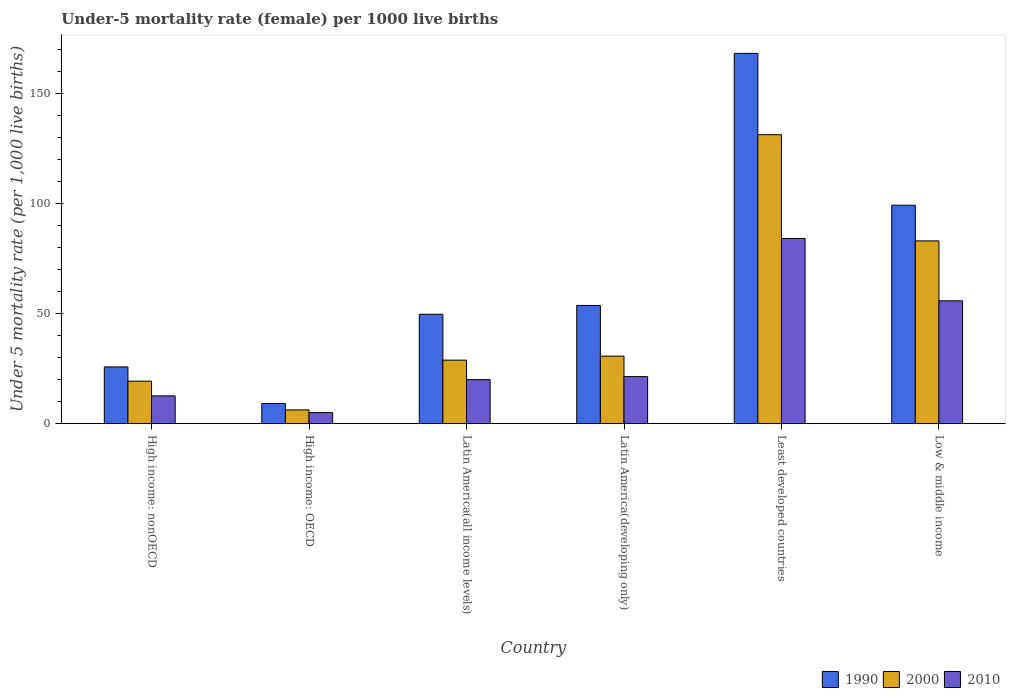How many groups of bars are there?
Offer a terse response. 6. Are the number of bars on each tick of the X-axis equal?
Offer a terse response. Yes. How many bars are there on the 1st tick from the left?
Ensure brevity in your answer.  3. In how many cases, is the number of bars for a given country not equal to the number of legend labels?
Provide a short and direct response. 0. What is the under-five mortality rate in 2000 in Latin America(all income levels)?
Offer a terse response. 28.87. Across all countries, what is the maximum under-five mortality rate in 2010?
Give a very brief answer. 84.09. Across all countries, what is the minimum under-five mortality rate in 2000?
Provide a succinct answer. 6.28. In which country was the under-five mortality rate in 2000 maximum?
Offer a terse response. Least developed countries. In which country was the under-five mortality rate in 1990 minimum?
Provide a short and direct response. High income: OECD. What is the total under-five mortality rate in 1990 in the graph?
Provide a succinct answer. 405.7. What is the difference between the under-five mortality rate in 2000 in Latin America(all income levels) and that in Low & middle income?
Your answer should be very brief. -54.13. What is the difference between the under-five mortality rate in 2010 in Latin America(all income levels) and the under-five mortality rate in 1990 in Least developed countries?
Ensure brevity in your answer.  -148.11. What is the average under-five mortality rate in 2010 per country?
Offer a terse response. 33.17. What is the difference between the under-five mortality rate of/in 2000 and under-five mortality rate of/in 2010 in Latin America(developing only)?
Your response must be concise. 9.3. What is the ratio of the under-five mortality rate in 1990 in Latin America(developing only) to that in Low & middle income?
Provide a succinct answer. 0.54. Is the difference between the under-five mortality rate in 2000 in Latin America(all income levels) and Least developed countries greater than the difference between the under-five mortality rate in 2010 in Latin America(all income levels) and Least developed countries?
Provide a short and direct response. No. What is the difference between the highest and the second highest under-five mortality rate in 2000?
Make the answer very short. -48.2. What is the difference between the highest and the lowest under-five mortality rate in 2000?
Provide a short and direct response. 124.92. In how many countries, is the under-five mortality rate in 2000 greater than the average under-five mortality rate in 2000 taken over all countries?
Provide a short and direct response. 2. Is the sum of the under-five mortality rate in 1990 in Latin America(developing only) and Low & middle income greater than the maximum under-five mortality rate in 2010 across all countries?
Give a very brief answer. Yes. Is it the case that in every country, the sum of the under-five mortality rate in 2010 and under-five mortality rate in 1990 is greater than the under-five mortality rate in 2000?
Give a very brief answer. Yes. Are all the bars in the graph horizontal?
Ensure brevity in your answer.  No. What is the difference between two consecutive major ticks on the Y-axis?
Provide a succinct answer. 50. Are the values on the major ticks of Y-axis written in scientific E-notation?
Offer a very short reply. No. How many legend labels are there?
Your answer should be very brief. 3. What is the title of the graph?
Ensure brevity in your answer.  Under-5 mortality rate (female) per 1000 live births. What is the label or title of the Y-axis?
Your response must be concise. Under 5 mortality rate (per 1,0 live births). What is the Under 5 mortality rate (per 1,000 live births) in 1990 in High income: nonOECD?
Give a very brief answer. 25.8. What is the Under 5 mortality rate (per 1,000 live births) in 2000 in High income: nonOECD?
Offer a very short reply. 19.34. What is the Under 5 mortality rate (per 1,000 live births) in 2010 in High income: nonOECD?
Give a very brief answer. 12.65. What is the Under 5 mortality rate (per 1,000 live births) of 1990 in High income: OECD?
Your answer should be compact. 9.18. What is the Under 5 mortality rate (per 1,000 live births) in 2000 in High income: OECD?
Your answer should be compact. 6.28. What is the Under 5 mortality rate (per 1,000 live births) of 2010 in High income: OECD?
Offer a terse response. 5.04. What is the Under 5 mortality rate (per 1,000 live births) of 1990 in Latin America(all income levels)?
Provide a succinct answer. 49.7. What is the Under 5 mortality rate (per 1,000 live births) in 2000 in Latin America(all income levels)?
Offer a very short reply. 28.87. What is the Under 5 mortality rate (per 1,000 live births) in 2010 in Latin America(all income levels)?
Your answer should be very brief. 20.02. What is the Under 5 mortality rate (per 1,000 live births) of 1990 in Latin America(developing only)?
Your response must be concise. 53.7. What is the Under 5 mortality rate (per 1,000 live births) in 2000 in Latin America(developing only)?
Ensure brevity in your answer.  30.7. What is the Under 5 mortality rate (per 1,000 live births) in 2010 in Latin America(developing only)?
Provide a short and direct response. 21.4. What is the Under 5 mortality rate (per 1,000 live births) of 1990 in Least developed countries?
Make the answer very short. 168.12. What is the Under 5 mortality rate (per 1,000 live births) in 2000 in Least developed countries?
Provide a short and direct response. 131.2. What is the Under 5 mortality rate (per 1,000 live births) of 2010 in Least developed countries?
Give a very brief answer. 84.09. What is the Under 5 mortality rate (per 1,000 live births) of 1990 in Low & middle income?
Provide a short and direct response. 99.2. What is the Under 5 mortality rate (per 1,000 live births) of 2000 in Low & middle income?
Your answer should be very brief. 83. What is the Under 5 mortality rate (per 1,000 live births) in 2010 in Low & middle income?
Your response must be concise. 55.8. Across all countries, what is the maximum Under 5 mortality rate (per 1,000 live births) of 1990?
Keep it short and to the point. 168.12. Across all countries, what is the maximum Under 5 mortality rate (per 1,000 live births) in 2000?
Your answer should be compact. 131.2. Across all countries, what is the maximum Under 5 mortality rate (per 1,000 live births) of 2010?
Provide a short and direct response. 84.09. Across all countries, what is the minimum Under 5 mortality rate (per 1,000 live births) in 1990?
Ensure brevity in your answer.  9.18. Across all countries, what is the minimum Under 5 mortality rate (per 1,000 live births) of 2000?
Make the answer very short. 6.28. Across all countries, what is the minimum Under 5 mortality rate (per 1,000 live births) in 2010?
Offer a terse response. 5.04. What is the total Under 5 mortality rate (per 1,000 live births) in 1990 in the graph?
Your response must be concise. 405.7. What is the total Under 5 mortality rate (per 1,000 live births) in 2000 in the graph?
Your answer should be compact. 299.39. What is the total Under 5 mortality rate (per 1,000 live births) of 2010 in the graph?
Provide a succinct answer. 198.99. What is the difference between the Under 5 mortality rate (per 1,000 live births) of 1990 in High income: nonOECD and that in High income: OECD?
Offer a very short reply. 16.61. What is the difference between the Under 5 mortality rate (per 1,000 live births) in 2000 in High income: nonOECD and that in High income: OECD?
Provide a short and direct response. 13.05. What is the difference between the Under 5 mortality rate (per 1,000 live births) in 2010 in High income: nonOECD and that in High income: OECD?
Give a very brief answer. 7.61. What is the difference between the Under 5 mortality rate (per 1,000 live births) of 1990 in High income: nonOECD and that in Latin America(all income levels)?
Your response must be concise. -23.9. What is the difference between the Under 5 mortality rate (per 1,000 live births) in 2000 in High income: nonOECD and that in Latin America(all income levels)?
Keep it short and to the point. -9.53. What is the difference between the Under 5 mortality rate (per 1,000 live births) of 2010 in High income: nonOECD and that in Latin America(all income levels)?
Keep it short and to the point. -7.37. What is the difference between the Under 5 mortality rate (per 1,000 live births) of 1990 in High income: nonOECD and that in Latin America(developing only)?
Your answer should be compact. -27.9. What is the difference between the Under 5 mortality rate (per 1,000 live births) of 2000 in High income: nonOECD and that in Latin America(developing only)?
Give a very brief answer. -11.36. What is the difference between the Under 5 mortality rate (per 1,000 live births) of 2010 in High income: nonOECD and that in Latin America(developing only)?
Provide a succinct answer. -8.75. What is the difference between the Under 5 mortality rate (per 1,000 live births) of 1990 in High income: nonOECD and that in Least developed countries?
Give a very brief answer. -142.33. What is the difference between the Under 5 mortality rate (per 1,000 live births) in 2000 in High income: nonOECD and that in Least developed countries?
Provide a succinct answer. -111.87. What is the difference between the Under 5 mortality rate (per 1,000 live births) of 2010 in High income: nonOECD and that in Least developed countries?
Ensure brevity in your answer.  -71.44. What is the difference between the Under 5 mortality rate (per 1,000 live births) of 1990 in High income: nonOECD and that in Low & middle income?
Make the answer very short. -73.4. What is the difference between the Under 5 mortality rate (per 1,000 live births) in 2000 in High income: nonOECD and that in Low & middle income?
Your answer should be compact. -63.66. What is the difference between the Under 5 mortality rate (per 1,000 live births) of 2010 in High income: nonOECD and that in Low & middle income?
Offer a very short reply. -43.15. What is the difference between the Under 5 mortality rate (per 1,000 live births) of 1990 in High income: OECD and that in Latin America(all income levels)?
Provide a succinct answer. -40.52. What is the difference between the Under 5 mortality rate (per 1,000 live births) of 2000 in High income: OECD and that in Latin America(all income levels)?
Ensure brevity in your answer.  -22.59. What is the difference between the Under 5 mortality rate (per 1,000 live births) in 2010 in High income: OECD and that in Latin America(all income levels)?
Provide a succinct answer. -14.98. What is the difference between the Under 5 mortality rate (per 1,000 live births) in 1990 in High income: OECD and that in Latin America(developing only)?
Offer a very short reply. -44.52. What is the difference between the Under 5 mortality rate (per 1,000 live births) in 2000 in High income: OECD and that in Latin America(developing only)?
Keep it short and to the point. -24.42. What is the difference between the Under 5 mortality rate (per 1,000 live births) in 2010 in High income: OECD and that in Latin America(developing only)?
Offer a terse response. -16.36. What is the difference between the Under 5 mortality rate (per 1,000 live births) in 1990 in High income: OECD and that in Least developed countries?
Your answer should be compact. -158.94. What is the difference between the Under 5 mortality rate (per 1,000 live births) in 2000 in High income: OECD and that in Least developed countries?
Give a very brief answer. -124.92. What is the difference between the Under 5 mortality rate (per 1,000 live births) of 2010 in High income: OECD and that in Least developed countries?
Give a very brief answer. -79.05. What is the difference between the Under 5 mortality rate (per 1,000 live births) in 1990 in High income: OECD and that in Low & middle income?
Offer a terse response. -90.02. What is the difference between the Under 5 mortality rate (per 1,000 live births) in 2000 in High income: OECD and that in Low & middle income?
Make the answer very short. -76.72. What is the difference between the Under 5 mortality rate (per 1,000 live births) of 2010 in High income: OECD and that in Low & middle income?
Make the answer very short. -50.76. What is the difference between the Under 5 mortality rate (per 1,000 live births) of 1990 in Latin America(all income levels) and that in Latin America(developing only)?
Offer a very short reply. -4. What is the difference between the Under 5 mortality rate (per 1,000 live births) of 2000 in Latin America(all income levels) and that in Latin America(developing only)?
Provide a succinct answer. -1.83. What is the difference between the Under 5 mortality rate (per 1,000 live births) of 2010 in Latin America(all income levels) and that in Latin America(developing only)?
Offer a terse response. -1.38. What is the difference between the Under 5 mortality rate (per 1,000 live births) in 1990 in Latin America(all income levels) and that in Least developed countries?
Offer a very short reply. -118.42. What is the difference between the Under 5 mortality rate (per 1,000 live births) in 2000 in Latin America(all income levels) and that in Least developed countries?
Your answer should be very brief. -102.34. What is the difference between the Under 5 mortality rate (per 1,000 live births) of 2010 in Latin America(all income levels) and that in Least developed countries?
Offer a terse response. -64.07. What is the difference between the Under 5 mortality rate (per 1,000 live births) in 1990 in Latin America(all income levels) and that in Low & middle income?
Your answer should be very brief. -49.5. What is the difference between the Under 5 mortality rate (per 1,000 live births) of 2000 in Latin America(all income levels) and that in Low & middle income?
Keep it short and to the point. -54.13. What is the difference between the Under 5 mortality rate (per 1,000 live births) of 2010 in Latin America(all income levels) and that in Low & middle income?
Provide a short and direct response. -35.78. What is the difference between the Under 5 mortality rate (per 1,000 live births) of 1990 in Latin America(developing only) and that in Least developed countries?
Ensure brevity in your answer.  -114.42. What is the difference between the Under 5 mortality rate (per 1,000 live births) in 2000 in Latin America(developing only) and that in Least developed countries?
Ensure brevity in your answer.  -100.5. What is the difference between the Under 5 mortality rate (per 1,000 live births) of 2010 in Latin America(developing only) and that in Least developed countries?
Your answer should be compact. -62.69. What is the difference between the Under 5 mortality rate (per 1,000 live births) of 1990 in Latin America(developing only) and that in Low & middle income?
Keep it short and to the point. -45.5. What is the difference between the Under 5 mortality rate (per 1,000 live births) in 2000 in Latin America(developing only) and that in Low & middle income?
Your response must be concise. -52.3. What is the difference between the Under 5 mortality rate (per 1,000 live births) in 2010 in Latin America(developing only) and that in Low & middle income?
Your answer should be very brief. -34.4. What is the difference between the Under 5 mortality rate (per 1,000 live births) of 1990 in Least developed countries and that in Low & middle income?
Offer a terse response. 68.92. What is the difference between the Under 5 mortality rate (per 1,000 live births) in 2000 in Least developed countries and that in Low & middle income?
Keep it short and to the point. 48.2. What is the difference between the Under 5 mortality rate (per 1,000 live births) in 2010 in Least developed countries and that in Low & middle income?
Make the answer very short. 28.29. What is the difference between the Under 5 mortality rate (per 1,000 live births) of 1990 in High income: nonOECD and the Under 5 mortality rate (per 1,000 live births) of 2000 in High income: OECD?
Your response must be concise. 19.52. What is the difference between the Under 5 mortality rate (per 1,000 live births) in 1990 in High income: nonOECD and the Under 5 mortality rate (per 1,000 live births) in 2010 in High income: OECD?
Keep it short and to the point. 20.76. What is the difference between the Under 5 mortality rate (per 1,000 live births) of 2000 in High income: nonOECD and the Under 5 mortality rate (per 1,000 live births) of 2010 in High income: OECD?
Ensure brevity in your answer.  14.3. What is the difference between the Under 5 mortality rate (per 1,000 live births) of 1990 in High income: nonOECD and the Under 5 mortality rate (per 1,000 live births) of 2000 in Latin America(all income levels)?
Provide a short and direct response. -3.07. What is the difference between the Under 5 mortality rate (per 1,000 live births) of 1990 in High income: nonOECD and the Under 5 mortality rate (per 1,000 live births) of 2010 in Latin America(all income levels)?
Your answer should be very brief. 5.78. What is the difference between the Under 5 mortality rate (per 1,000 live births) of 2000 in High income: nonOECD and the Under 5 mortality rate (per 1,000 live births) of 2010 in Latin America(all income levels)?
Make the answer very short. -0.68. What is the difference between the Under 5 mortality rate (per 1,000 live births) in 1990 in High income: nonOECD and the Under 5 mortality rate (per 1,000 live births) in 2000 in Latin America(developing only)?
Your response must be concise. -4.9. What is the difference between the Under 5 mortality rate (per 1,000 live births) of 1990 in High income: nonOECD and the Under 5 mortality rate (per 1,000 live births) of 2010 in Latin America(developing only)?
Offer a very short reply. 4.4. What is the difference between the Under 5 mortality rate (per 1,000 live births) of 2000 in High income: nonOECD and the Under 5 mortality rate (per 1,000 live births) of 2010 in Latin America(developing only)?
Make the answer very short. -2.06. What is the difference between the Under 5 mortality rate (per 1,000 live births) in 1990 in High income: nonOECD and the Under 5 mortality rate (per 1,000 live births) in 2000 in Least developed countries?
Your answer should be very brief. -105.41. What is the difference between the Under 5 mortality rate (per 1,000 live births) of 1990 in High income: nonOECD and the Under 5 mortality rate (per 1,000 live births) of 2010 in Least developed countries?
Your answer should be very brief. -58.29. What is the difference between the Under 5 mortality rate (per 1,000 live births) of 2000 in High income: nonOECD and the Under 5 mortality rate (per 1,000 live births) of 2010 in Least developed countries?
Give a very brief answer. -64.75. What is the difference between the Under 5 mortality rate (per 1,000 live births) of 1990 in High income: nonOECD and the Under 5 mortality rate (per 1,000 live births) of 2000 in Low & middle income?
Ensure brevity in your answer.  -57.2. What is the difference between the Under 5 mortality rate (per 1,000 live births) of 1990 in High income: nonOECD and the Under 5 mortality rate (per 1,000 live births) of 2010 in Low & middle income?
Your answer should be compact. -30. What is the difference between the Under 5 mortality rate (per 1,000 live births) in 2000 in High income: nonOECD and the Under 5 mortality rate (per 1,000 live births) in 2010 in Low & middle income?
Your response must be concise. -36.46. What is the difference between the Under 5 mortality rate (per 1,000 live births) of 1990 in High income: OECD and the Under 5 mortality rate (per 1,000 live births) of 2000 in Latin America(all income levels)?
Ensure brevity in your answer.  -19.68. What is the difference between the Under 5 mortality rate (per 1,000 live births) in 1990 in High income: OECD and the Under 5 mortality rate (per 1,000 live births) in 2010 in Latin America(all income levels)?
Offer a terse response. -10.83. What is the difference between the Under 5 mortality rate (per 1,000 live births) of 2000 in High income: OECD and the Under 5 mortality rate (per 1,000 live births) of 2010 in Latin America(all income levels)?
Your answer should be compact. -13.74. What is the difference between the Under 5 mortality rate (per 1,000 live births) of 1990 in High income: OECD and the Under 5 mortality rate (per 1,000 live births) of 2000 in Latin America(developing only)?
Provide a succinct answer. -21.52. What is the difference between the Under 5 mortality rate (per 1,000 live births) of 1990 in High income: OECD and the Under 5 mortality rate (per 1,000 live births) of 2010 in Latin America(developing only)?
Offer a very short reply. -12.22. What is the difference between the Under 5 mortality rate (per 1,000 live births) in 2000 in High income: OECD and the Under 5 mortality rate (per 1,000 live births) in 2010 in Latin America(developing only)?
Your answer should be compact. -15.12. What is the difference between the Under 5 mortality rate (per 1,000 live births) in 1990 in High income: OECD and the Under 5 mortality rate (per 1,000 live births) in 2000 in Least developed countries?
Your response must be concise. -122.02. What is the difference between the Under 5 mortality rate (per 1,000 live births) of 1990 in High income: OECD and the Under 5 mortality rate (per 1,000 live births) of 2010 in Least developed countries?
Keep it short and to the point. -74.9. What is the difference between the Under 5 mortality rate (per 1,000 live births) in 2000 in High income: OECD and the Under 5 mortality rate (per 1,000 live births) in 2010 in Least developed countries?
Give a very brief answer. -77.81. What is the difference between the Under 5 mortality rate (per 1,000 live births) in 1990 in High income: OECD and the Under 5 mortality rate (per 1,000 live births) in 2000 in Low & middle income?
Offer a very short reply. -73.82. What is the difference between the Under 5 mortality rate (per 1,000 live births) of 1990 in High income: OECD and the Under 5 mortality rate (per 1,000 live births) of 2010 in Low & middle income?
Your response must be concise. -46.62. What is the difference between the Under 5 mortality rate (per 1,000 live births) in 2000 in High income: OECD and the Under 5 mortality rate (per 1,000 live births) in 2010 in Low & middle income?
Provide a succinct answer. -49.52. What is the difference between the Under 5 mortality rate (per 1,000 live births) of 1990 in Latin America(all income levels) and the Under 5 mortality rate (per 1,000 live births) of 2000 in Latin America(developing only)?
Your response must be concise. 19. What is the difference between the Under 5 mortality rate (per 1,000 live births) in 1990 in Latin America(all income levels) and the Under 5 mortality rate (per 1,000 live births) in 2010 in Latin America(developing only)?
Give a very brief answer. 28.3. What is the difference between the Under 5 mortality rate (per 1,000 live births) in 2000 in Latin America(all income levels) and the Under 5 mortality rate (per 1,000 live births) in 2010 in Latin America(developing only)?
Keep it short and to the point. 7.47. What is the difference between the Under 5 mortality rate (per 1,000 live births) of 1990 in Latin America(all income levels) and the Under 5 mortality rate (per 1,000 live births) of 2000 in Least developed countries?
Provide a succinct answer. -81.5. What is the difference between the Under 5 mortality rate (per 1,000 live births) of 1990 in Latin America(all income levels) and the Under 5 mortality rate (per 1,000 live births) of 2010 in Least developed countries?
Your response must be concise. -34.39. What is the difference between the Under 5 mortality rate (per 1,000 live births) of 2000 in Latin America(all income levels) and the Under 5 mortality rate (per 1,000 live births) of 2010 in Least developed countries?
Make the answer very short. -55.22. What is the difference between the Under 5 mortality rate (per 1,000 live births) in 1990 in Latin America(all income levels) and the Under 5 mortality rate (per 1,000 live births) in 2000 in Low & middle income?
Provide a short and direct response. -33.3. What is the difference between the Under 5 mortality rate (per 1,000 live births) in 1990 in Latin America(all income levels) and the Under 5 mortality rate (per 1,000 live births) in 2010 in Low & middle income?
Ensure brevity in your answer.  -6.1. What is the difference between the Under 5 mortality rate (per 1,000 live births) of 2000 in Latin America(all income levels) and the Under 5 mortality rate (per 1,000 live births) of 2010 in Low & middle income?
Your answer should be compact. -26.93. What is the difference between the Under 5 mortality rate (per 1,000 live births) of 1990 in Latin America(developing only) and the Under 5 mortality rate (per 1,000 live births) of 2000 in Least developed countries?
Provide a succinct answer. -77.5. What is the difference between the Under 5 mortality rate (per 1,000 live births) of 1990 in Latin America(developing only) and the Under 5 mortality rate (per 1,000 live births) of 2010 in Least developed countries?
Make the answer very short. -30.39. What is the difference between the Under 5 mortality rate (per 1,000 live births) of 2000 in Latin America(developing only) and the Under 5 mortality rate (per 1,000 live births) of 2010 in Least developed countries?
Provide a short and direct response. -53.39. What is the difference between the Under 5 mortality rate (per 1,000 live births) of 1990 in Latin America(developing only) and the Under 5 mortality rate (per 1,000 live births) of 2000 in Low & middle income?
Your response must be concise. -29.3. What is the difference between the Under 5 mortality rate (per 1,000 live births) of 1990 in Latin America(developing only) and the Under 5 mortality rate (per 1,000 live births) of 2010 in Low & middle income?
Your answer should be compact. -2.1. What is the difference between the Under 5 mortality rate (per 1,000 live births) in 2000 in Latin America(developing only) and the Under 5 mortality rate (per 1,000 live births) in 2010 in Low & middle income?
Your answer should be very brief. -25.1. What is the difference between the Under 5 mortality rate (per 1,000 live births) in 1990 in Least developed countries and the Under 5 mortality rate (per 1,000 live births) in 2000 in Low & middle income?
Provide a short and direct response. 85.12. What is the difference between the Under 5 mortality rate (per 1,000 live births) in 1990 in Least developed countries and the Under 5 mortality rate (per 1,000 live births) in 2010 in Low & middle income?
Make the answer very short. 112.32. What is the difference between the Under 5 mortality rate (per 1,000 live births) in 2000 in Least developed countries and the Under 5 mortality rate (per 1,000 live births) in 2010 in Low & middle income?
Offer a terse response. 75.4. What is the average Under 5 mortality rate (per 1,000 live births) of 1990 per country?
Give a very brief answer. 67.62. What is the average Under 5 mortality rate (per 1,000 live births) of 2000 per country?
Provide a short and direct response. 49.9. What is the average Under 5 mortality rate (per 1,000 live births) in 2010 per country?
Your answer should be very brief. 33.17. What is the difference between the Under 5 mortality rate (per 1,000 live births) in 1990 and Under 5 mortality rate (per 1,000 live births) in 2000 in High income: nonOECD?
Keep it short and to the point. 6.46. What is the difference between the Under 5 mortality rate (per 1,000 live births) of 1990 and Under 5 mortality rate (per 1,000 live births) of 2010 in High income: nonOECD?
Provide a short and direct response. 13.15. What is the difference between the Under 5 mortality rate (per 1,000 live births) of 2000 and Under 5 mortality rate (per 1,000 live births) of 2010 in High income: nonOECD?
Offer a very short reply. 6.69. What is the difference between the Under 5 mortality rate (per 1,000 live births) in 1990 and Under 5 mortality rate (per 1,000 live births) in 2000 in High income: OECD?
Ensure brevity in your answer.  2.9. What is the difference between the Under 5 mortality rate (per 1,000 live births) in 1990 and Under 5 mortality rate (per 1,000 live births) in 2010 in High income: OECD?
Your answer should be very brief. 4.14. What is the difference between the Under 5 mortality rate (per 1,000 live births) in 2000 and Under 5 mortality rate (per 1,000 live births) in 2010 in High income: OECD?
Provide a short and direct response. 1.24. What is the difference between the Under 5 mortality rate (per 1,000 live births) of 1990 and Under 5 mortality rate (per 1,000 live births) of 2000 in Latin America(all income levels)?
Make the answer very short. 20.83. What is the difference between the Under 5 mortality rate (per 1,000 live births) in 1990 and Under 5 mortality rate (per 1,000 live births) in 2010 in Latin America(all income levels)?
Keep it short and to the point. 29.68. What is the difference between the Under 5 mortality rate (per 1,000 live births) in 2000 and Under 5 mortality rate (per 1,000 live births) in 2010 in Latin America(all income levels)?
Offer a very short reply. 8.85. What is the difference between the Under 5 mortality rate (per 1,000 live births) of 1990 and Under 5 mortality rate (per 1,000 live births) of 2010 in Latin America(developing only)?
Your answer should be compact. 32.3. What is the difference between the Under 5 mortality rate (per 1,000 live births) in 2000 and Under 5 mortality rate (per 1,000 live births) in 2010 in Latin America(developing only)?
Your answer should be compact. 9.3. What is the difference between the Under 5 mortality rate (per 1,000 live births) in 1990 and Under 5 mortality rate (per 1,000 live births) in 2000 in Least developed countries?
Keep it short and to the point. 36.92. What is the difference between the Under 5 mortality rate (per 1,000 live births) of 1990 and Under 5 mortality rate (per 1,000 live births) of 2010 in Least developed countries?
Make the answer very short. 84.04. What is the difference between the Under 5 mortality rate (per 1,000 live births) of 2000 and Under 5 mortality rate (per 1,000 live births) of 2010 in Least developed countries?
Provide a short and direct response. 47.12. What is the difference between the Under 5 mortality rate (per 1,000 live births) in 1990 and Under 5 mortality rate (per 1,000 live births) in 2010 in Low & middle income?
Your response must be concise. 43.4. What is the difference between the Under 5 mortality rate (per 1,000 live births) of 2000 and Under 5 mortality rate (per 1,000 live births) of 2010 in Low & middle income?
Ensure brevity in your answer.  27.2. What is the ratio of the Under 5 mortality rate (per 1,000 live births) of 1990 in High income: nonOECD to that in High income: OECD?
Your answer should be compact. 2.81. What is the ratio of the Under 5 mortality rate (per 1,000 live births) in 2000 in High income: nonOECD to that in High income: OECD?
Your response must be concise. 3.08. What is the ratio of the Under 5 mortality rate (per 1,000 live births) in 2010 in High income: nonOECD to that in High income: OECD?
Offer a terse response. 2.51. What is the ratio of the Under 5 mortality rate (per 1,000 live births) in 1990 in High income: nonOECD to that in Latin America(all income levels)?
Provide a succinct answer. 0.52. What is the ratio of the Under 5 mortality rate (per 1,000 live births) of 2000 in High income: nonOECD to that in Latin America(all income levels)?
Make the answer very short. 0.67. What is the ratio of the Under 5 mortality rate (per 1,000 live births) in 2010 in High income: nonOECD to that in Latin America(all income levels)?
Give a very brief answer. 0.63. What is the ratio of the Under 5 mortality rate (per 1,000 live births) of 1990 in High income: nonOECD to that in Latin America(developing only)?
Keep it short and to the point. 0.48. What is the ratio of the Under 5 mortality rate (per 1,000 live births) of 2000 in High income: nonOECD to that in Latin America(developing only)?
Your response must be concise. 0.63. What is the ratio of the Under 5 mortality rate (per 1,000 live births) of 2010 in High income: nonOECD to that in Latin America(developing only)?
Your response must be concise. 0.59. What is the ratio of the Under 5 mortality rate (per 1,000 live births) of 1990 in High income: nonOECD to that in Least developed countries?
Provide a succinct answer. 0.15. What is the ratio of the Under 5 mortality rate (per 1,000 live births) of 2000 in High income: nonOECD to that in Least developed countries?
Ensure brevity in your answer.  0.15. What is the ratio of the Under 5 mortality rate (per 1,000 live births) of 2010 in High income: nonOECD to that in Least developed countries?
Give a very brief answer. 0.15. What is the ratio of the Under 5 mortality rate (per 1,000 live births) of 1990 in High income: nonOECD to that in Low & middle income?
Offer a terse response. 0.26. What is the ratio of the Under 5 mortality rate (per 1,000 live births) of 2000 in High income: nonOECD to that in Low & middle income?
Your response must be concise. 0.23. What is the ratio of the Under 5 mortality rate (per 1,000 live births) of 2010 in High income: nonOECD to that in Low & middle income?
Provide a short and direct response. 0.23. What is the ratio of the Under 5 mortality rate (per 1,000 live births) in 1990 in High income: OECD to that in Latin America(all income levels)?
Your answer should be compact. 0.18. What is the ratio of the Under 5 mortality rate (per 1,000 live births) in 2000 in High income: OECD to that in Latin America(all income levels)?
Your response must be concise. 0.22. What is the ratio of the Under 5 mortality rate (per 1,000 live births) of 2010 in High income: OECD to that in Latin America(all income levels)?
Offer a very short reply. 0.25. What is the ratio of the Under 5 mortality rate (per 1,000 live births) of 1990 in High income: OECD to that in Latin America(developing only)?
Make the answer very short. 0.17. What is the ratio of the Under 5 mortality rate (per 1,000 live births) of 2000 in High income: OECD to that in Latin America(developing only)?
Ensure brevity in your answer.  0.2. What is the ratio of the Under 5 mortality rate (per 1,000 live births) in 2010 in High income: OECD to that in Latin America(developing only)?
Provide a succinct answer. 0.24. What is the ratio of the Under 5 mortality rate (per 1,000 live births) in 1990 in High income: OECD to that in Least developed countries?
Your response must be concise. 0.05. What is the ratio of the Under 5 mortality rate (per 1,000 live births) of 2000 in High income: OECD to that in Least developed countries?
Ensure brevity in your answer.  0.05. What is the ratio of the Under 5 mortality rate (per 1,000 live births) in 2010 in High income: OECD to that in Least developed countries?
Your answer should be very brief. 0.06. What is the ratio of the Under 5 mortality rate (per 1,000 live births) in 1990 in High income: OECD to that in Low & middle income?
Your response must be concise. 0.09. What is the ratio of the Under 5 mortality rate (per 1,000 live births) of 2000 in High income: OECD to that in Low & middle income?
Ensure brevity in your answer.  0.08. What is the ratio of the Under 5 mortality rate (per 1,000 live births) in 2010 in High income: OECD to that in Low & middle income?
Give a very brief answer. 0.09. What is the ratio of the Under 5 mortality rate (per 1,000 live births) in 1990 in Latin America(all income levels) to that in Latin America(developing only)?
Provide a succinct answer. 0.93. What is the ratio of the Under 5 mortality rate (per 1,000 live births) in 2000 in Latin America(all income levels) to that in Latin America(developing only)?
Your answer should be very brief. 0.94. What is the ratio of the Under 5 mortality rate (per 1,000 live births) in 2010 in Latin America(all income levels) to that in Latin America(developing only)?
Offer a terse response. 0.94. What is the ratio of the Under 5 mortality rate (per 1,000 live births) in 1990 in Latin America(all income levels) to that in Least developed countries?
Your answer should be very brief. 0.3. What is the ratio of the Under 5 mortality rate (per 1,000 live births) in 2000 in Latin America(all income levels) to that in Least developed countries?
Your answer should be very brief. 0.22. What is the ratio of the Under 5 mortality rate (per 1,000 live births) of 2010 in Latin America(all income levels) to that in Least developed countries?
Make the answer very short. 0.24. What is the ratio of the Under 5 mortality rate (per 1,000 live births) of 1990 in Latin America(all income levels) to that in Low & middle income?
Your answer should be compact. 0.5. What is the ratio of the Under 5 mortality rate (per 1,000 live births) in 2000 in Latin America(all income levels) to that in Low & middle income?
Offer a terse response. 0.35. What is the ratio of the Under 5 mortality rate (per 1,000 live births) in 2010 in Latin America(all income levels) to that in Low & middle income?
Make the answer very short. 0.36. What is the ratio of the Under 5 mortality rate (per 1,000 live births) in 1990 in Latin America(developing only) to that in Least developed countries?
Your response must be concise. 0.32. What is the ratio of the Under 5 mortality rate (per 1,000 live births) of 2000 in Latin America(developing only) to that in Least developed countries?
Ensure brevity in your answer.  0.23. What is the ratio of the Under 5 mortality rate (per 1,000 live births) in 2010 in Latin America(developing only) to that in Least developed countries?
Provide a succinct answer. 0.25. What is the ratio of the Under 5 mortality rate (per 1,000 live births) in 1990 in Latin America(developing only) to that in Low & middle income?
Your response must be concise. 0.54. What is the ratio of the Under 5 mortality rate (per 1,000 live births) in 2000 in Latin America(developing only) to that in Low & middle income?
Offer a terse response. 0.37. What is the ratio of the Under 5 mortality rate (per 1,000 live births) in 2010 in Latin America(developing only) to that in Low & middle income?
Your answer should be compact. 0.38. What is the ratio of the Under 5 mortality rate (per 1,000 live births) in 1990 in Least developed countries to that in Low & middle income?
Provide a short and direct response. 1.69. What is the ratio of the Under 5 mortality rate (per 1,000 live births) of 2000 in Least developed countries to that in Low & middle income?
Give a very brief answer. 1.58. What is the ratio of the Under 5 mortality rate (per 1,000 live births) in 2010 in Least developed countries to that in Low & middle income?
Offer a terse response. 1.51. What is the difference between the highest and the second highest Under 5 mortality rate (per 1,000 live births) of 1990?
Make the answer very short. 68.92. What is the difference between the highest and the second highest Under 5 mortality rate (per 1,000 live births) in 2000?
Your response must be concise. 48.2. What is the difference between the highest and the second highest Under 5 mortality rate (per 1,000 live births) in 2010?
Your answer should be compact. 28.29. What is the difference between the highest and the lowest Under 5 mortality rate (per 1,000 live births) in 1990?
Make the answer very short. 158.94. What is the difference between the highest and the lowest Under 5 mortality rate (per 1,000 live births) in 2000?
Ensure brevity in your answer.  124.92. What is the difference between the highest and the lowest Under 5 mortality rate (per 1,000 live births) in 2010?
Your response must be concise. 79.05. 